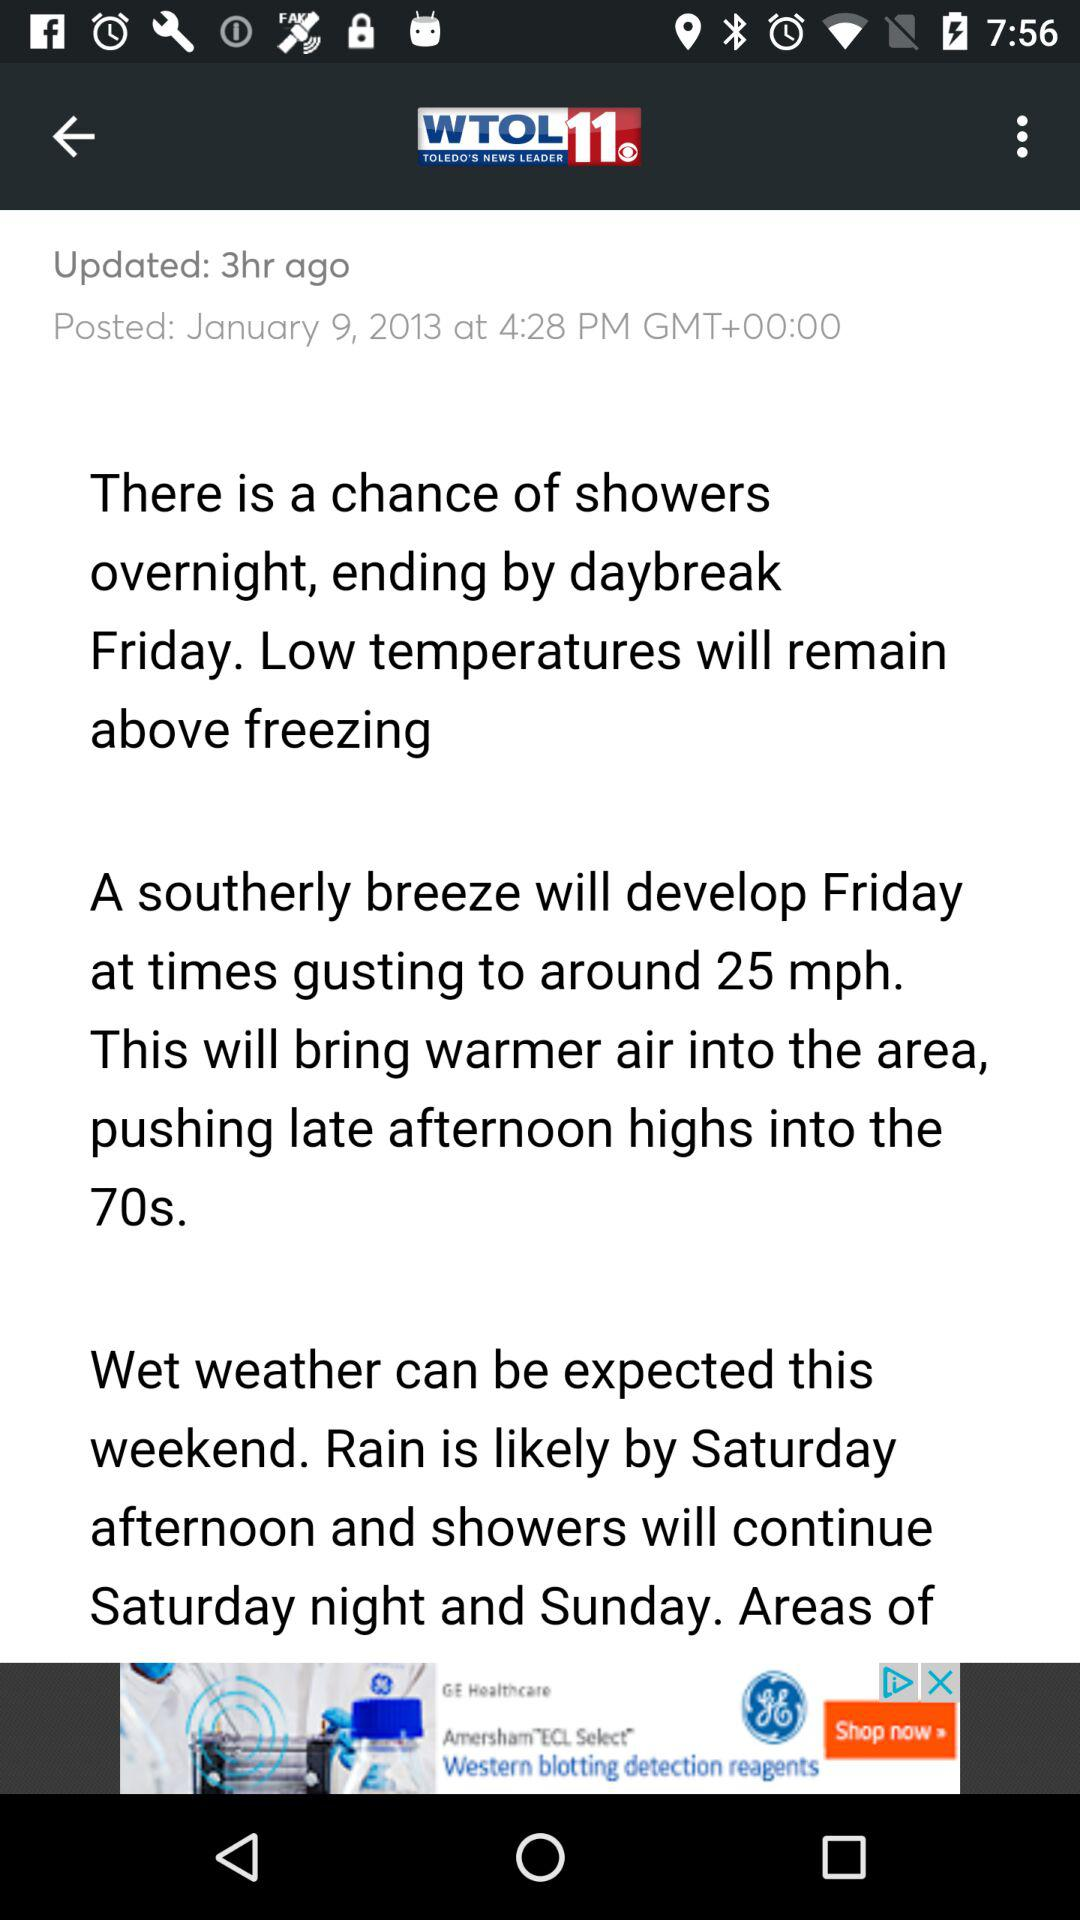What is the date? The date is January 9, 2013. 